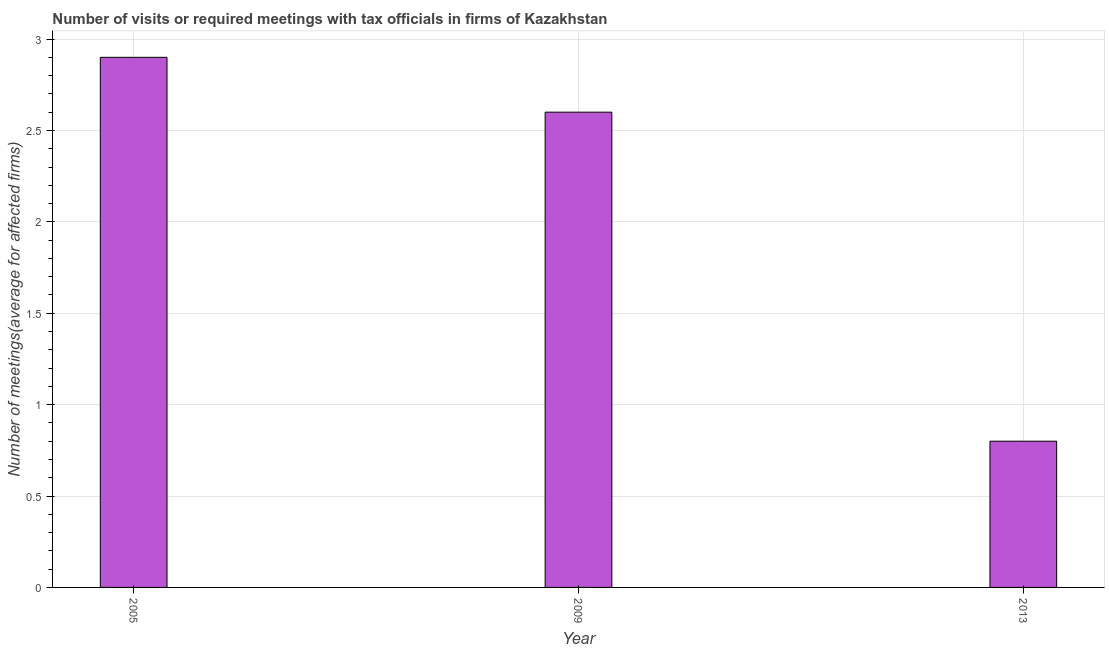Does the graph contain grids?
Provide a succinct answer. Yes. What is the title of the graph?
Make the answer very short. Number of visits or required meetings with tax officials in firms of Kazakhstan. What is the label or title of the X-axis?
Provide a succinct answer. Year. What is the label or title of the Y-axis?
Keep it short and to the point. Number of meetings(average for affected firms). Across all years, what is the minimum number of required meetings with tax officials?
Provide a succinct answer. 0.8. In which year was the number of required meetings with tax officials minimum?
Provide a short and direct response. 2013. What is the difference between the number of required meetings with tax officials in 2009 and 2013?
Your answer should be very brief. 1.8. What is the median number of required meetings with tax officials?
Provide a short and direct response. 2.6. In how many years, is the number of required meetings with tax officials greater than 0.4 ?
Ensure brevity in your answer.  3. Do a majority of the years between 2013 and 2005 (inclusive) have number of required meetings with tax officials greater than 1.7 ?
Keep it short and to the point. Yes. What is the ratio of the number of required meetings with tax officials in 2005 to that in 2013?
Your answer should be compact. 3.62. Is the number of required meetings with tax officials in 2005 less than that in 2013?
Make the answer very short. No. What is the difference between the highest and the second highest number of required meetings with tax officials?
Keep it short and to the point. 0.3. How many bars are there?
Your response must be concise. 3. How many years are there in the graph?
Make the answer very short. 3. Are the values on the major ticks of Y-axis written in scientific E-notation?
Your answer should be very brief. No. What is the Number of meetings(average for affected firms) of 2009?
Your response must be concise. 2.6. What is the difference between the Number of meetings(average for affected firms) in 2005 and 2009?
Your answer should be compact. 0.3. What is the difference between the Number of meetings(average for affected firms) in 2005 and 2013?
Give a very brief answer. 2.1. What is the ratio of the Number of meetings(average for affected firms) in 2005 to that in 2009?
Offer a terse response. 1.11. What is the ratio of the Number of meetings(average for affected firms) in 2005 to that in 2013?
Give a very brief answer. 3.62. 